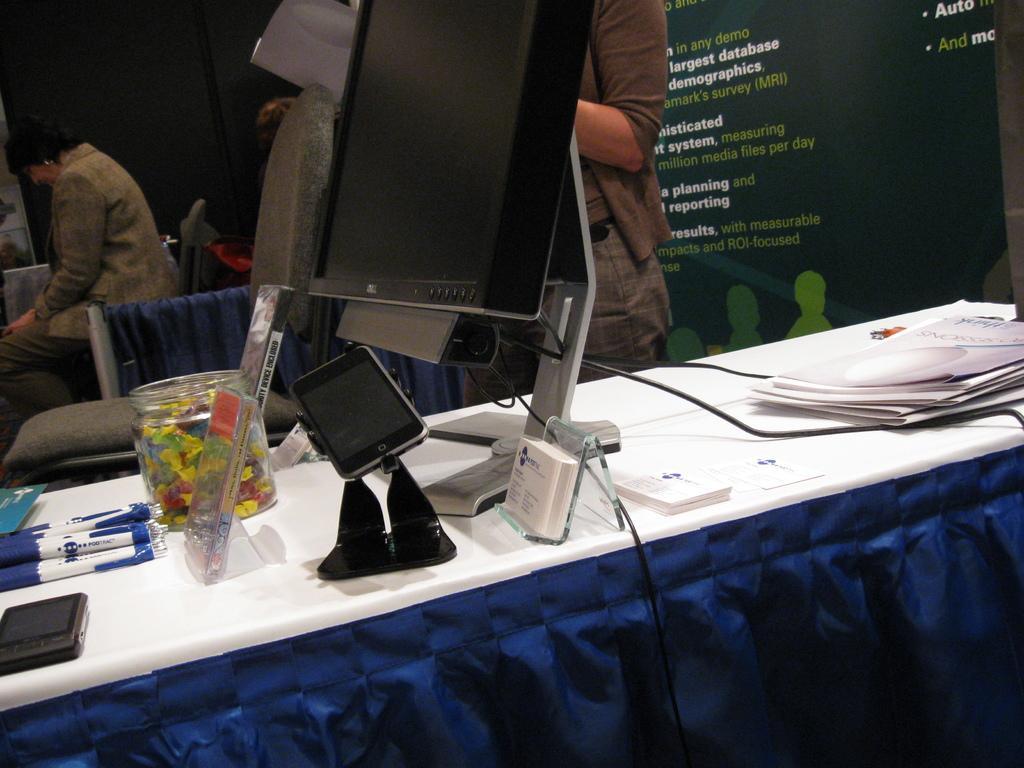Please provide a concise description of this image. In this image I can see a system, a mobile, few papers, pens, a glass bowl on the table. I can also see a blue color curtain, background I can see a person standing wearing brown color dress and I can also see a person sitting on the chair. Background I can also see a screen. 